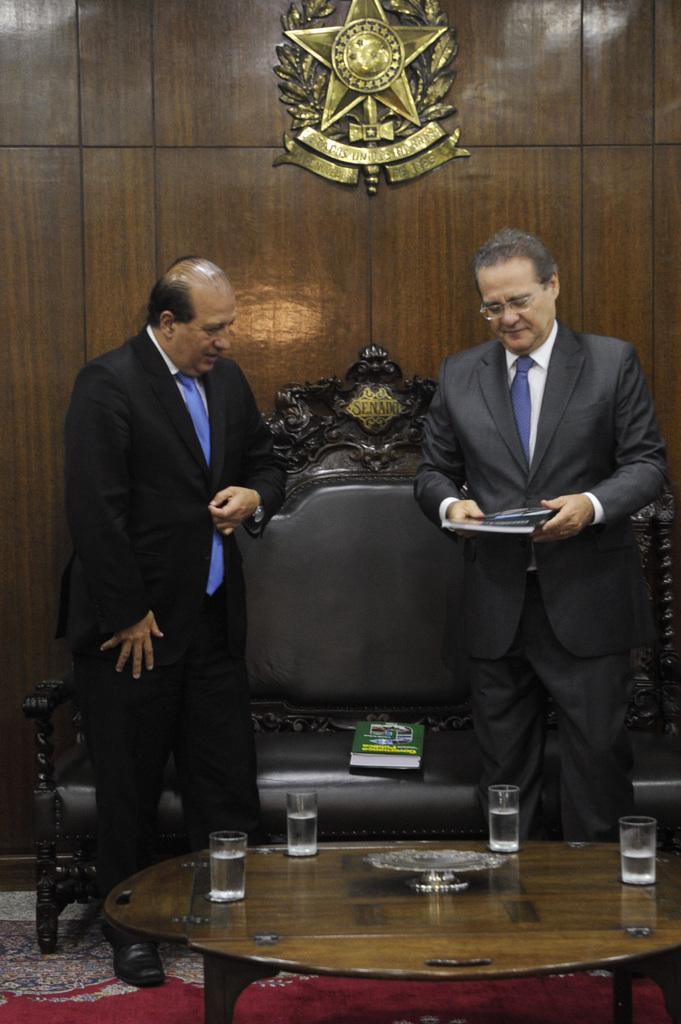Could you give a brief overview of what you see in this image? In the image the two persons behind the person one big chair is there and the room consist of are standing on the floor the room has the chair and table and table consist of 4 glasses. 